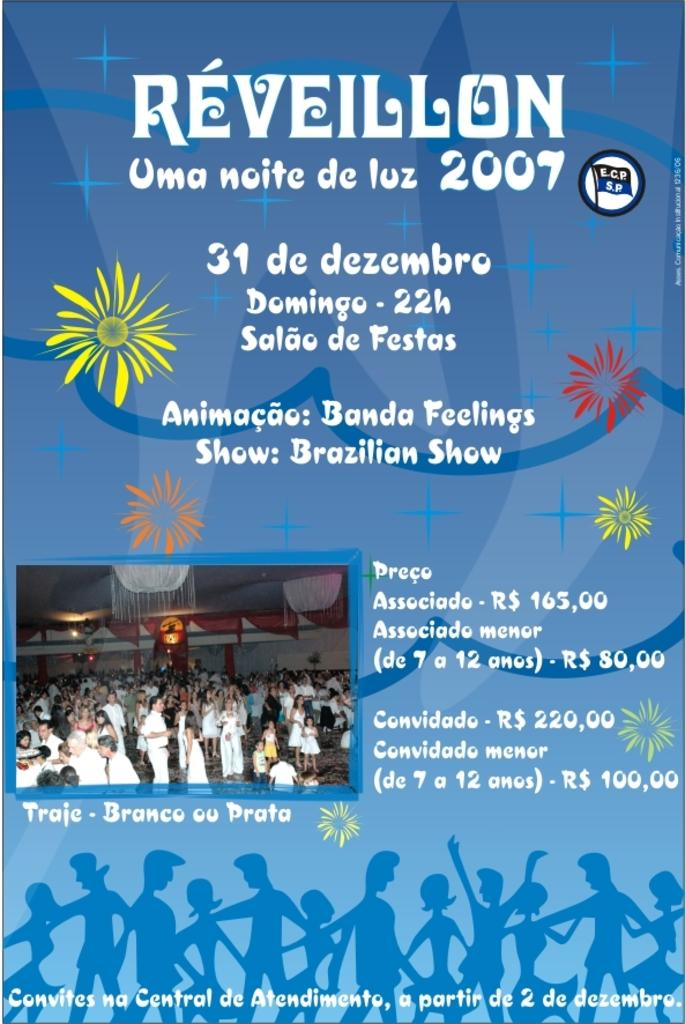<image>
Give a short and clear explanation of the subsequent image. a poster advertisement for Reveillon which will happen in 2007 